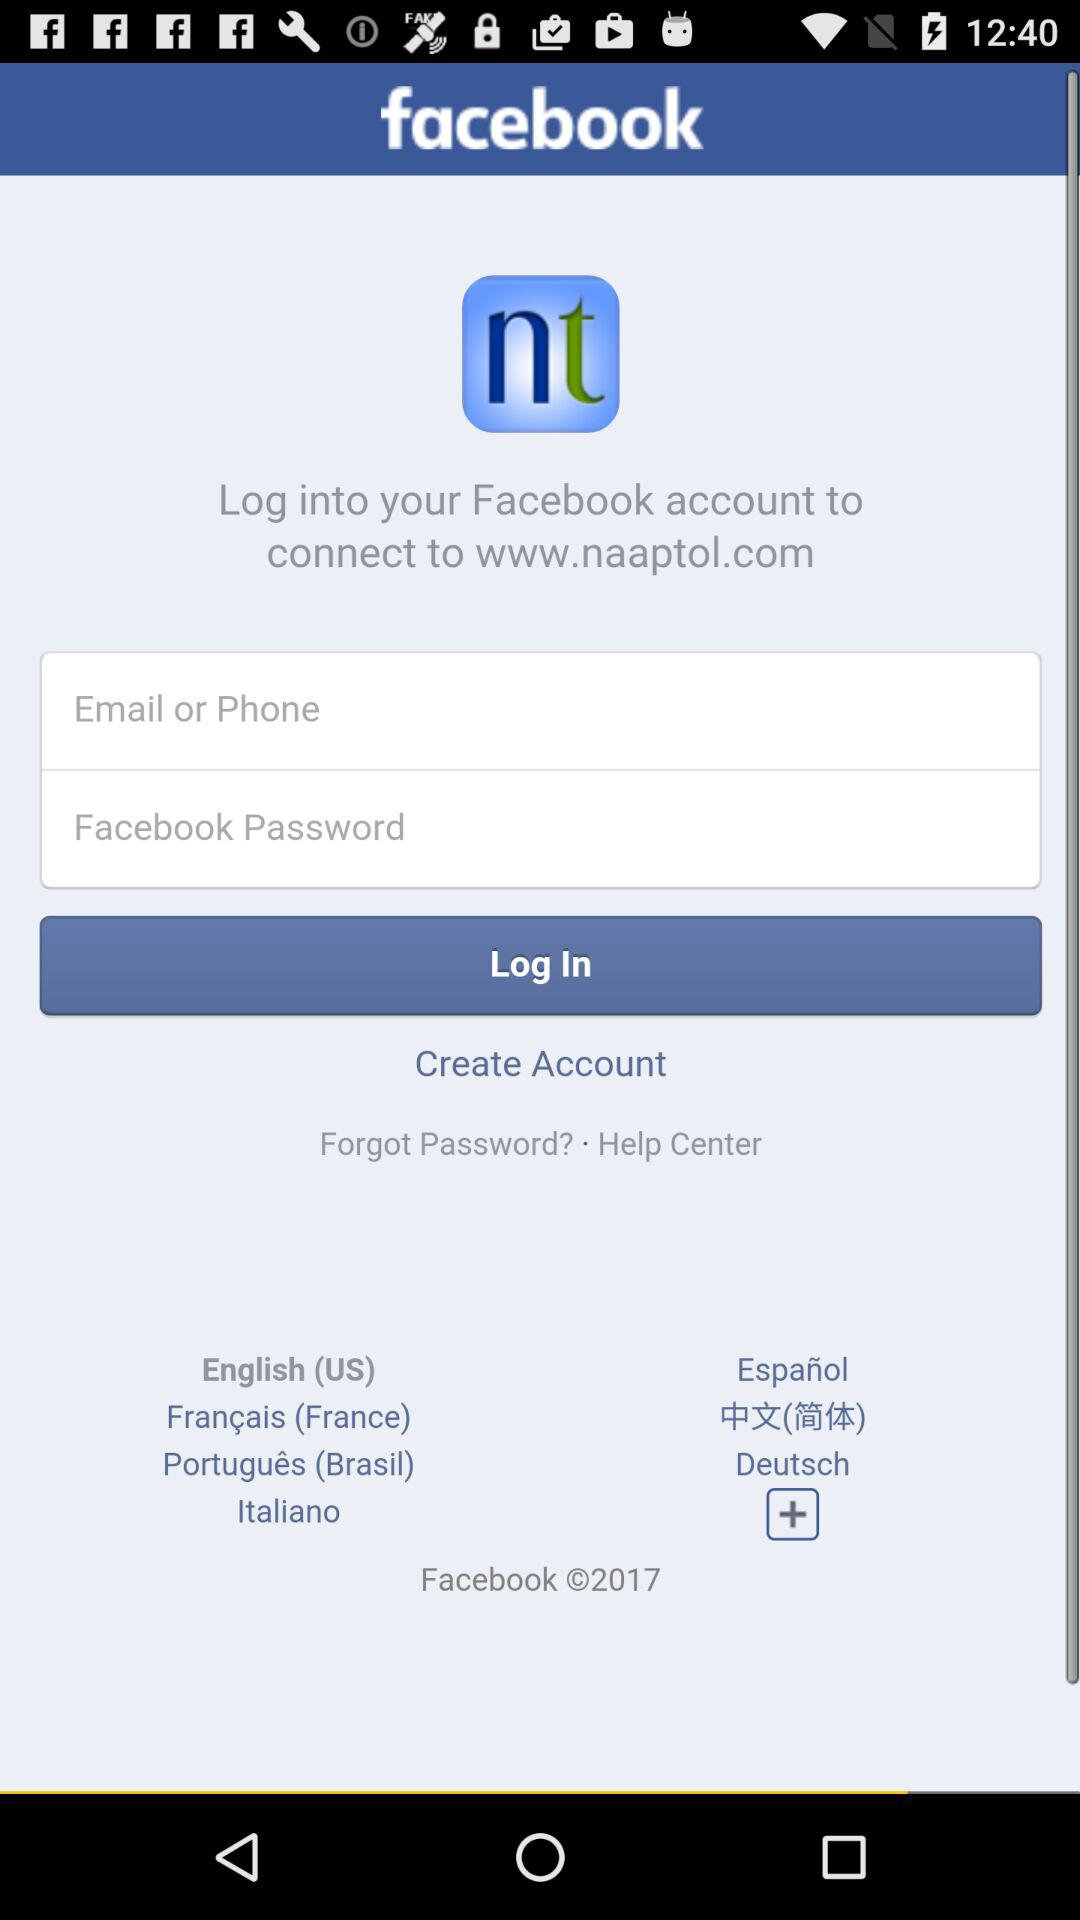Which version of facebook is used?
When the provided information is insufficient, respond with <no answer>. <no answer> 